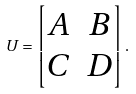Convert formula to latex. <formula><loc_0><loc_0><loc_500><loc_500>U = \begin{bmatrix} A & B \\ C & D \end{bmatrix} .</formula> 